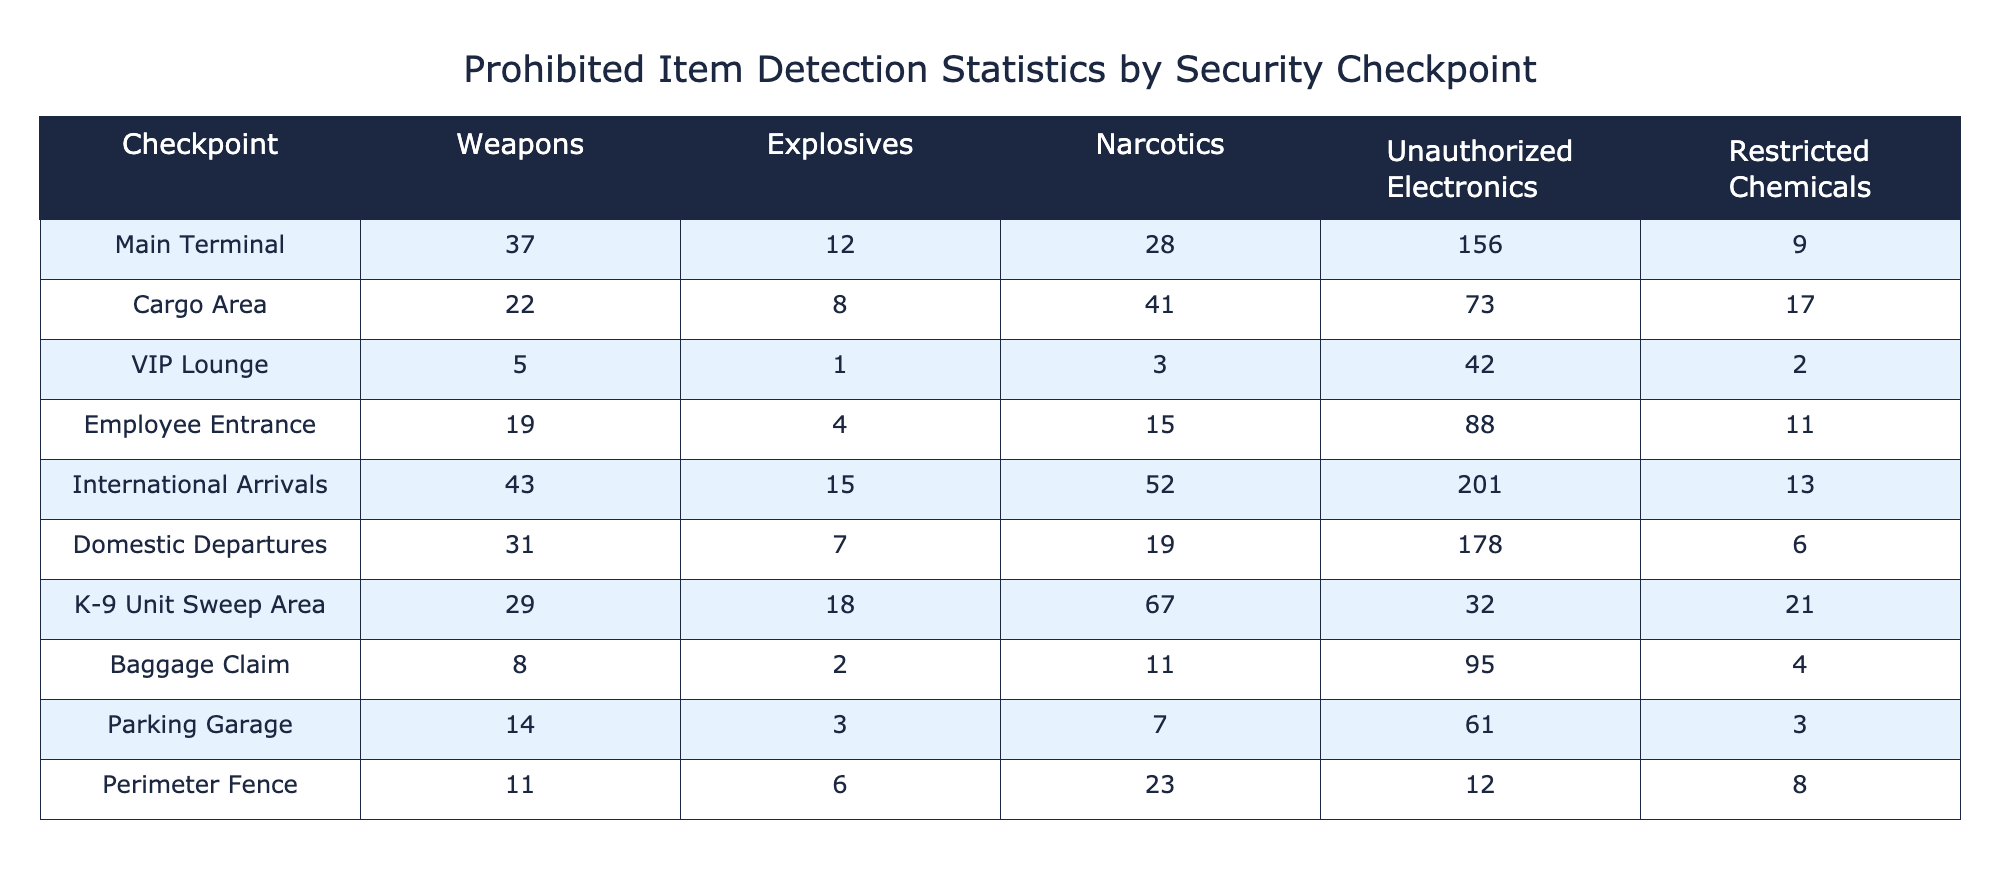What is the total number of weapons detected at the Main Terminal? According to the table, the number of weapons detected at the Main Terminal is directly listed as 37.
Answer: 37 Which security checkpoint detected the most explosives? In the table, looking at the column for explosives, International Arrivals shows the highest count at 15 when compared with other checkpoints.
Answer: International Arrivals How many unauthorized electronics were detected at the Domestic Departures? The number of unauthorized electronics detected at Domestic Departures is recorded in the table as 178.
Answer: 178 What is the average number of narcotics detected across all checkpoints? To compute the average, we sum the narcotics detected across all checkpoints: 28 + 41 + 3 + 15 + 52 + 19 + 67 + 11 + 7 + 23 =  266. There are 10 checkpoints, so we divide 266 by 10 to get an average of 26.6.
Answer: 26.6 Is there any checkpoint where restricted chemicals were not detected? By examining the restricted chemicals column in the table, we find that all checkpoints have some number of detected restricted chemicals, even if counts are low. Thus, there is no checkpoint without detected restricted chemicals.
Answer: No Which checkpoint has the highest total number of prohibited items detected? To find this, we sum the counts for all items detected at each checkpoint. Checking the totals: Main Terminal (282), Cargo Area (161), VIP Lounge (48), Employee Entrance (137), International Arrivals (353), Domestic Departures (261), K-9 Unit Sweep Area (167), Baggage Claim (120), Parking Garage (88), Perimeter Fence (63). By comparing, the International Arrivals has the highest total at 353.
Answer: International Arrivals How many more weapons were detected at K-9 Unit Sweep Area compared to the Parking Garage? At K-9 Unit Sweep Area, 29 weapons were detected, while at the Parking Garage, the number is 14. The difference is 29 - 14 = 15.
Answer: 15 Are there more instances of unauthorized electronics or explosives detected in the Employee Entrance? In the Employee Entrance, 88 unauthorized electronics are detected compared to 4 explosives. Since 88 is greater, we conclude that unauthorized electronics were detected more frequently.
Answer: Yes How many total narcotics were detected at the Cargo Area and Employee Entrance combined? We find the number of narcotics at the Cargo Area is 41 and at Employee Entrance is 15. Adding these gives 41 + 15 = 56 total narcotics detected at both checkpoints.
Answer: 56 